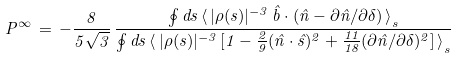Convert formula to latex. <formula><loc_0><loc_0><loc_500><loc_500>P ^ { \infty } \, = \, - \frac { 8 } { 5 \sqrt { 3 } } \, \frac { { \oint d s \, \langle \, | \rho ( s ) | ^ { - 3 } \, \hat { b } \cdot ( \hat { n } - \partial \hat { n } / \partial \delta ) \, \rangle } _ { s } } { { \oint d s \, \langle \, | \rho ( s ) | ^ { - 3 } \, [ 1 - \frac { 2 } { 9 } ( \hat { n } \cdot \hat { s } ) ^ { 2 } + \frac { 1 1 } { 1 8 } ( \partial \hat { n } / \partial \delta ) ^ { 2 } ] \, \rangle } _ { s } }</formula> 